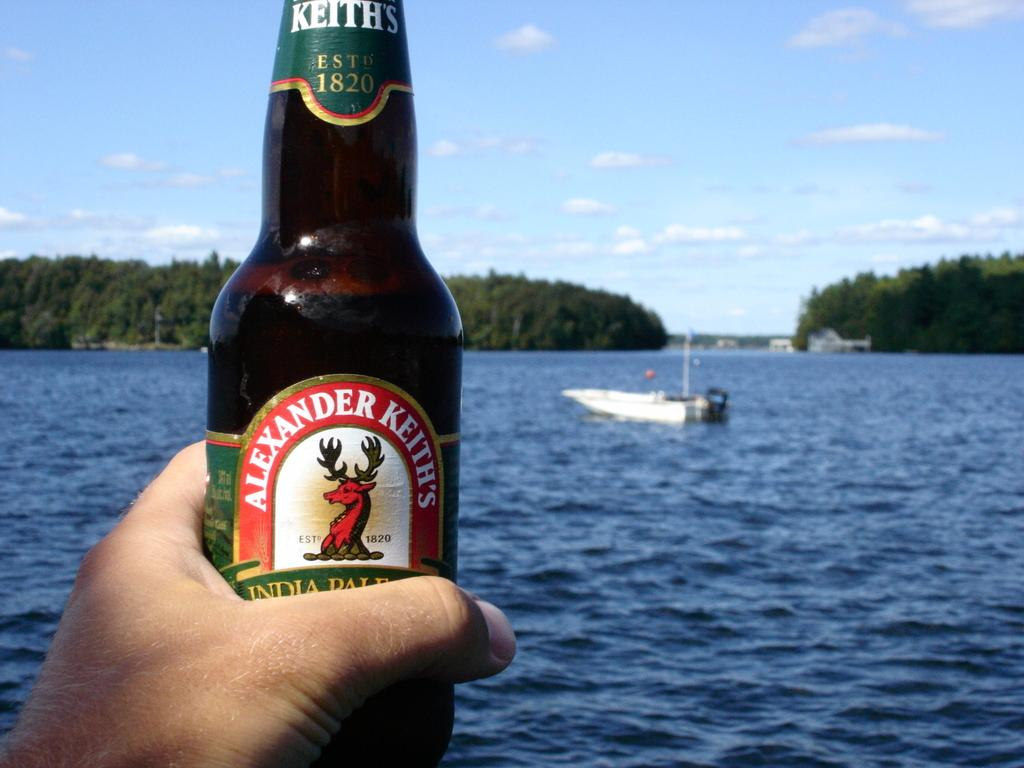<image>
Provide a brief description of the given image. Someone is holding an Alexander Keith's bottle with a lake in the background. 